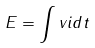Convert formula to latex. <formula><loc_0><loc_0><loc_500><loc_500>E = \int v i d t</formula> 